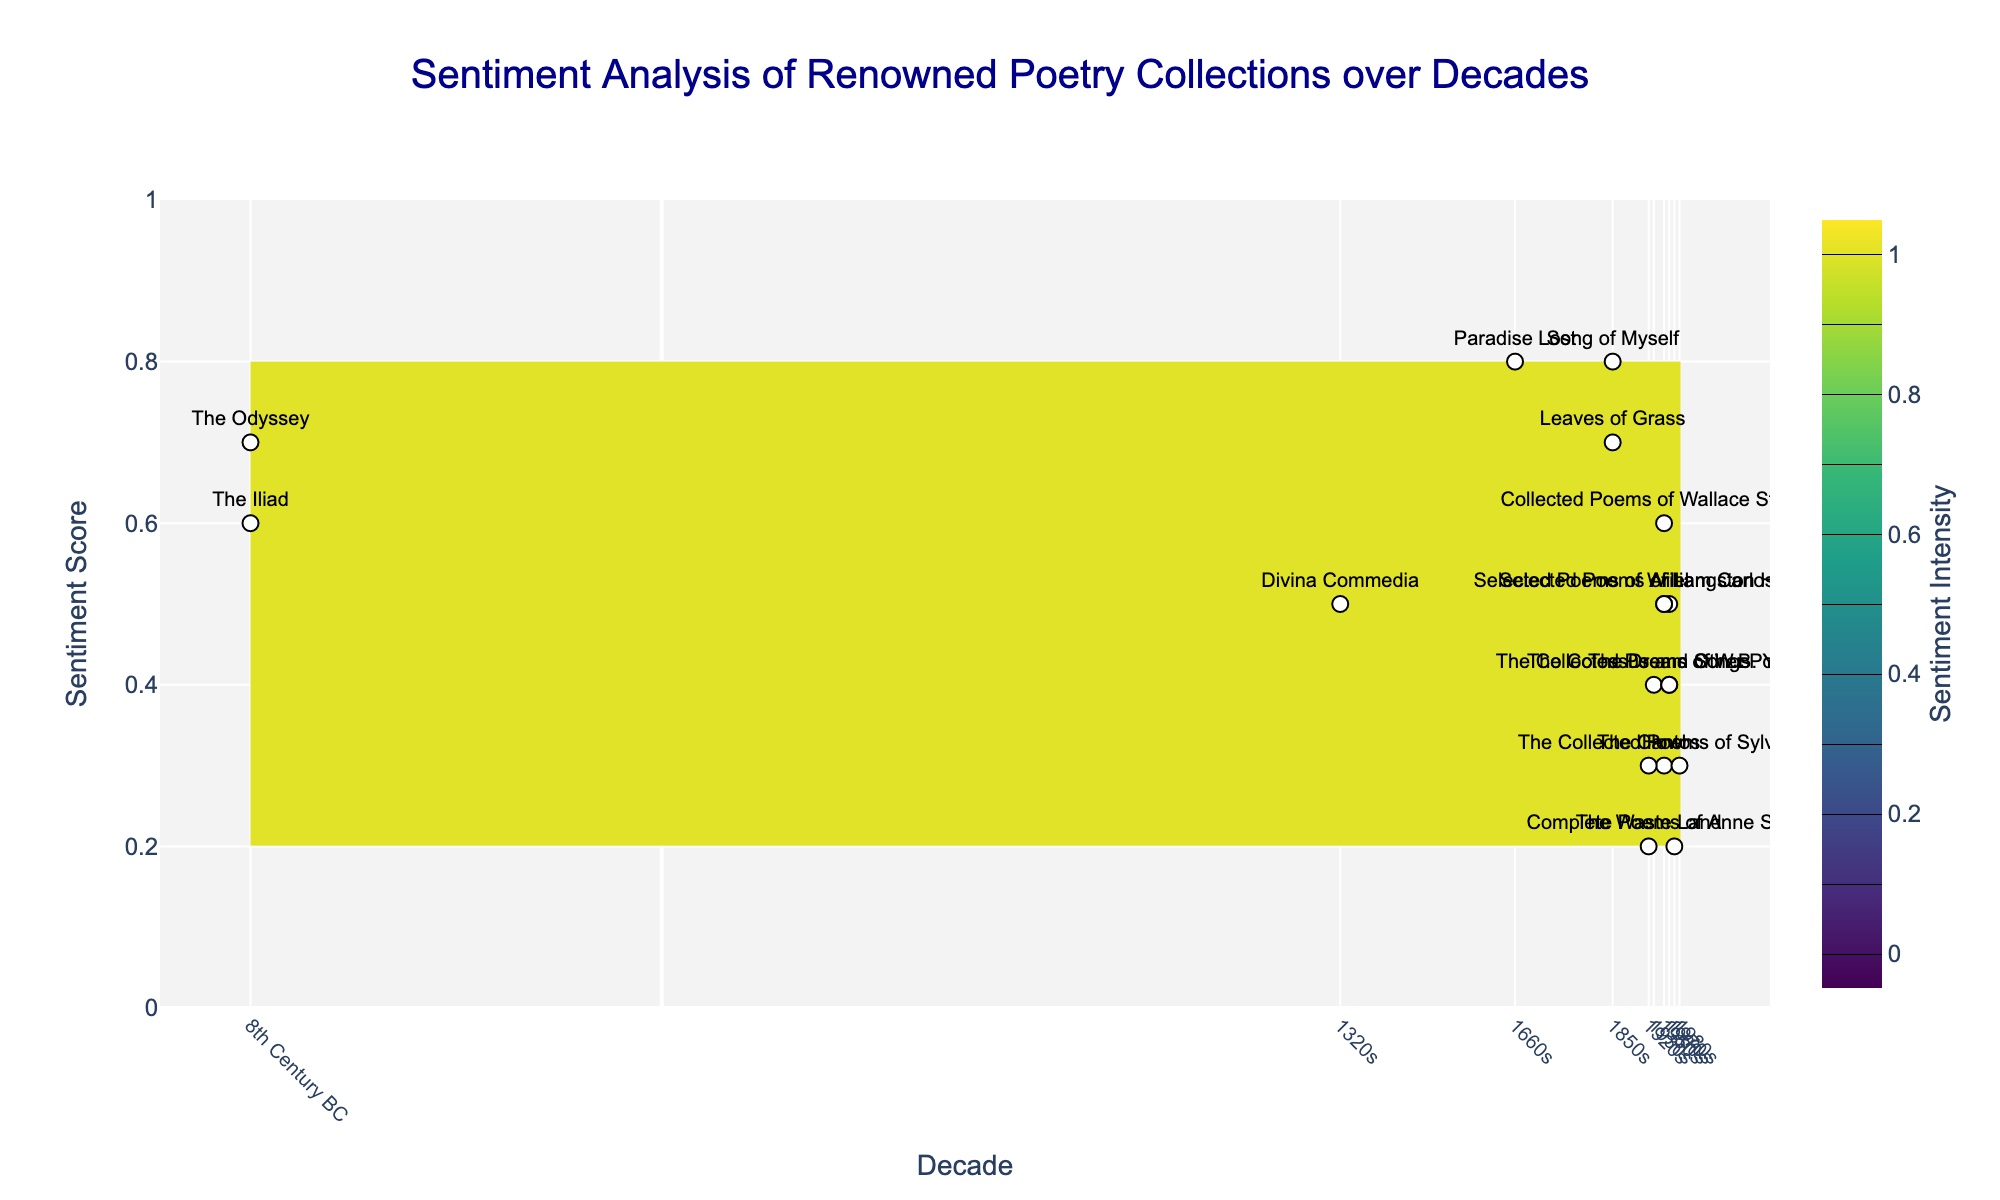What is the range of sentiment scores shown on the y-axis? By observing the y-axis on the figure, the sentiment scores range from the minimum value to the maximum value indicated.
Answer: 0 to 1 Which poetry collection from the 1950s has the highest sentiment score? To find the poetry collection with the highest sentiment score from the 1950s, look at the 1950s data points on the graph and identify the collection with the highest y-axis value.
Answer: "Collected Poems of Wallace Stevens" How many decades are represented on the x-axis? Count the number of distinct decade labels on the x-axis to determine the total number of decades represented in the figure.
Answer: 9 Which poetry collection has the lowest sentiment score? Identify the data point with the lowest y-axis value and refer to its label to find the corresponding poetry collection.
Answer: "Complete Poems of Anne Sexton" What is the sentiment score difference between "Leaves of Grass" and "Howl"? Find the y-axis values for "Leaves of Grass" and "Howl", then subtract their sentiment scores to find the difference.
Answer: 0.7 - 0.3 = 0.4 Between the 1930s and the 1960s, which decade has a higher average sentiment score based on the collections presented? Calculate the average sentiment score for the poetry collections in the 1930s and 1960s, then compare the two averages.
Answer: 0.45 for 1960s is higher than 0.4 for 1930s Which poetry collection from the 19th century has the highest sentiment score? Look at the data points from the 19th century (1850s) and find the one with the highest y-axis value.
Answer: "Song of Myself" Is the sentiment score of "The Odyssey" higher than that of "The Iliad"? Compare the y-axis values of "The Odyssey" and "The Iliad" to determine which one is higher.
Answer: Yes What is the sentiment score of the oldest poetry collection? Find the sentiment score for the poetry collection from the oldest decade, which is "8th Century BC".
Answer: 0.7 for "The Odyssey" Which poetry collections from the 1920s have sentiment scores between 0.2 and 0.4? Identify the data points labeled with 1920s and check their y-axis values to see which ones lie between 0.2 and 0.4.
Answer: "The Waste Land" and "The Cantos" 